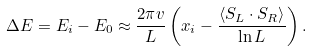Convert formula to latex. <formula><loc_0><loc_0><loc_500><loc_500>\Delta E = E _ { i } - E _ { 0 } \approx \frac { 2 \pi v } { L } \left ( x _ { i } - \frac { \left \langle { S } _ { L } \cdot { S } _ { R } \right \rangle } { \ln L } \right ) .</formula> 